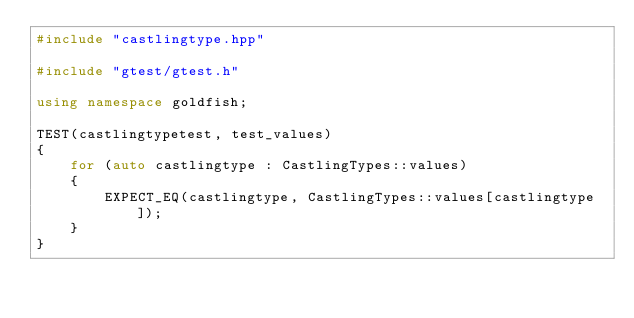Convert code to text. <code><loc_0><loc_0><loc_500><loc_500><_C++_>#include "castlingtype.hpp"

#include "gtest/gtest.h"

using namespace goldfish;

TEST(castlingtypetest, test_values)
{
    for (auto castlingtype : CastlingTypes::values)
    {
        EXPECT_EQ(castlingtype, CastlingTypes::values[castlingtype]);
    }
}
</code> 